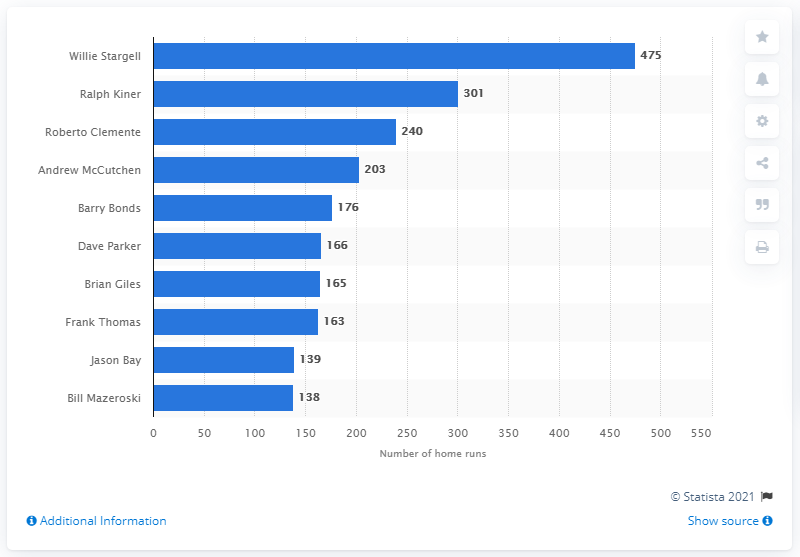Draw attention to some important aspects in this diagram. Willie Stargell has hit a total of 475 home runs. The Pittsburgh Pirates franchise record for most home runs belongs to Willie Stargell, who hit a total of (amount) home runs during his tenure with the team. 